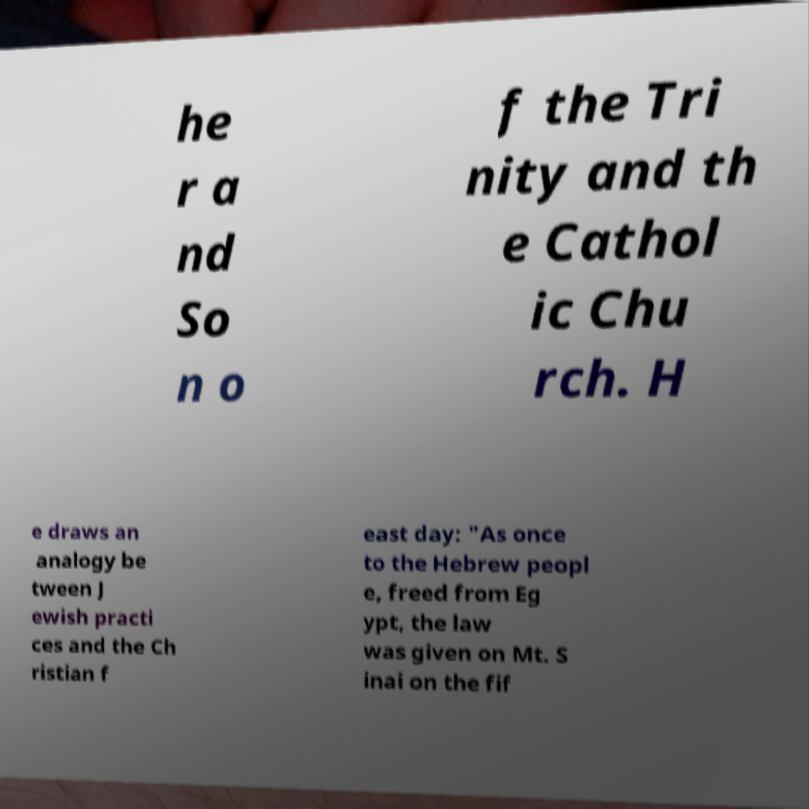For documentation purposes, I need the text within this image transcribed. Could you provide that? he r a nd So n o f the Tri nity and th e Cathol ic Chu rch. H e draws an analogy be tween J ewish practi ces and the Ch ristian f east day: "As once to the Hebrew peopl e, freed from Eg ypt, the law was given on Mt. S inai on the fif 